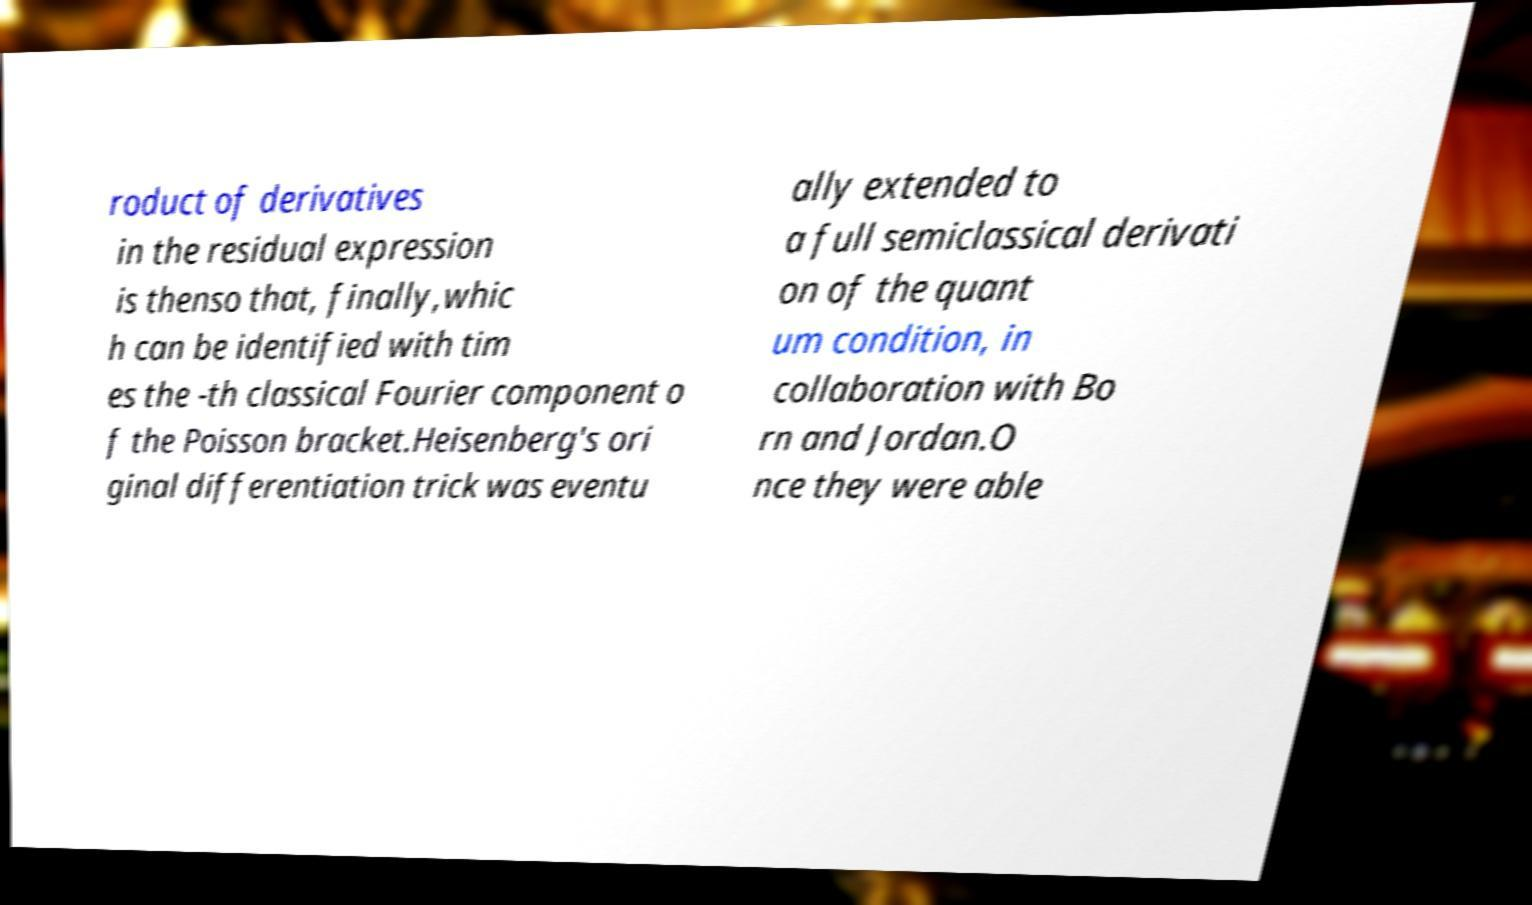Can you accurately transcribe the text from the provided image for me? roduct of derivatives in the residual expression is thenso that, finally,whic h can be identified with tim es the -th classical Fourier component o f the Poisson bracket.Heisenberg's ori ginal differentiation trick was eventu ally extended to a full semiclassical derivati on of the quant um condition, in collaboration with Bo rn and Jordan.O nce they were able 